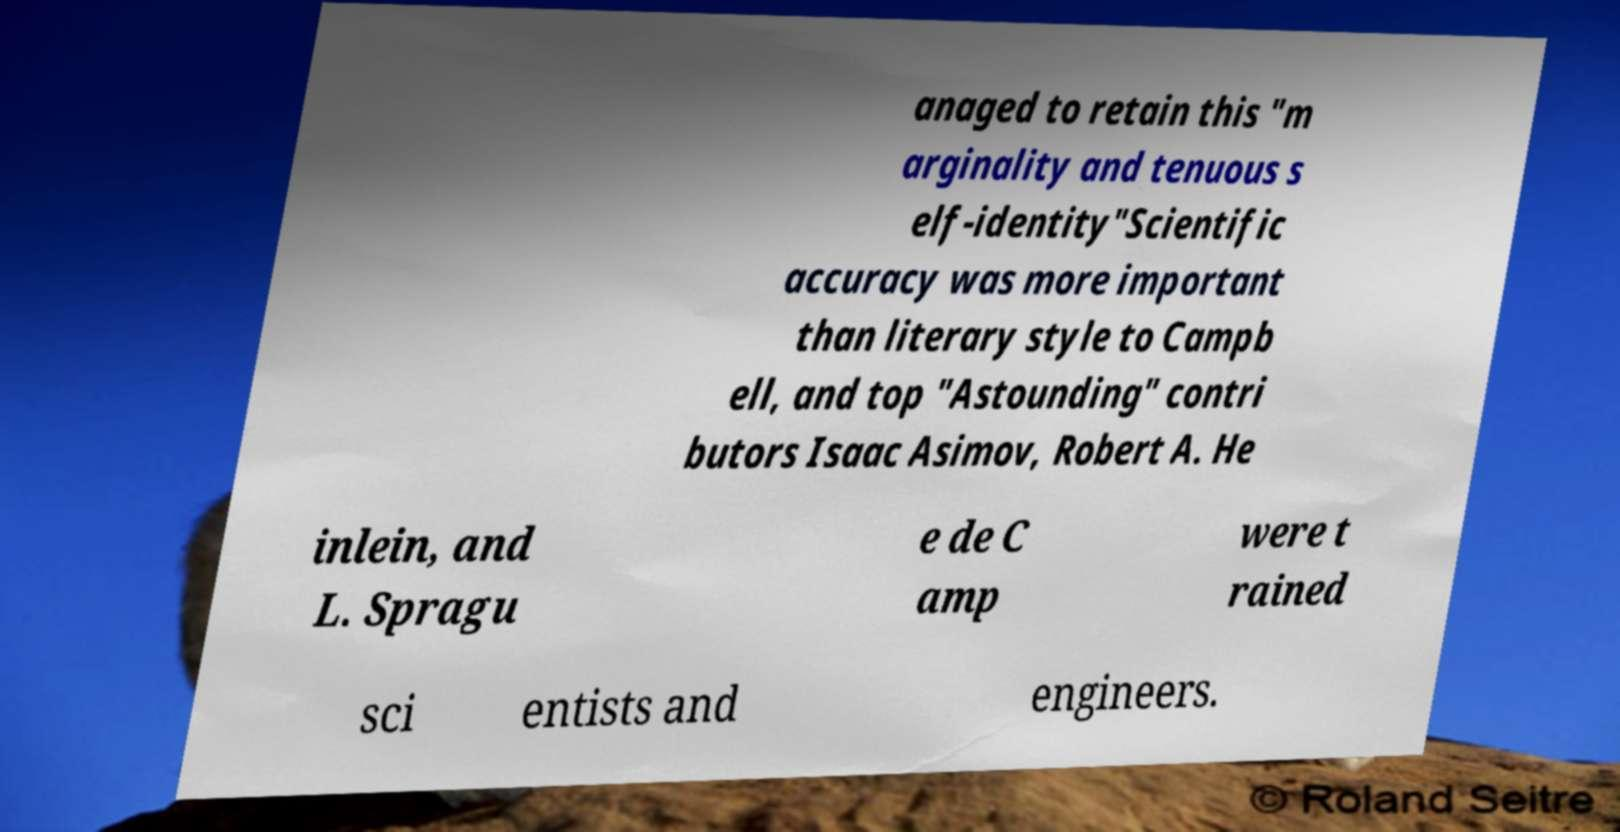What messages or text are displayed in this image? I need them in a readable, typed format. anaged to retain this "m arginality and tenuous s elf-identity"Scientific accuracy was more important than literary style to Campb ell, and top "Astounding" contri butors Isaac Asimov, Robert A. He inlein, and L. Spragu e de C amp were t rained sci entists and engineers. 